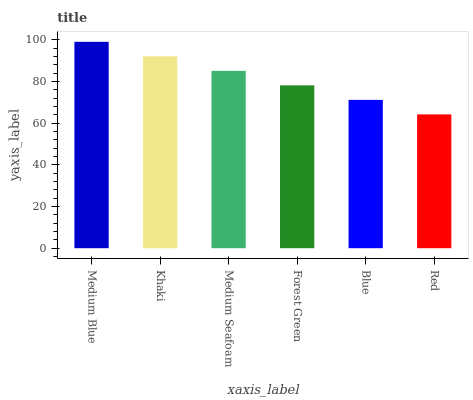Is Red the minimum?
Answer yes or no. Yes. Is Medium Blue the maximum?
Answer yes or no. Yes. Is Khaki the minimum?
Answer yes or no. No. Is Khaki the maximum?
Answer yes or no. No. Is Medium Blue greater than Khaki?
Answer yes or no. Yes. Is Khaki less than Medium Blue?
Answer yes or no. Yes. Is Khaki greater than Medium Blue?
Answer yes or no. No. Is Medium Blue less than Khaki?
Answer yes or no. No. Is Medium Seafoam the high median?
Answer yes or no. Yes. Is Forest Green the low median?
Answer yes or no. Yes. Is Forest Green the high median?
Answer yes or no. No. Is Khaki the low median?
Answer yes or no. No. 